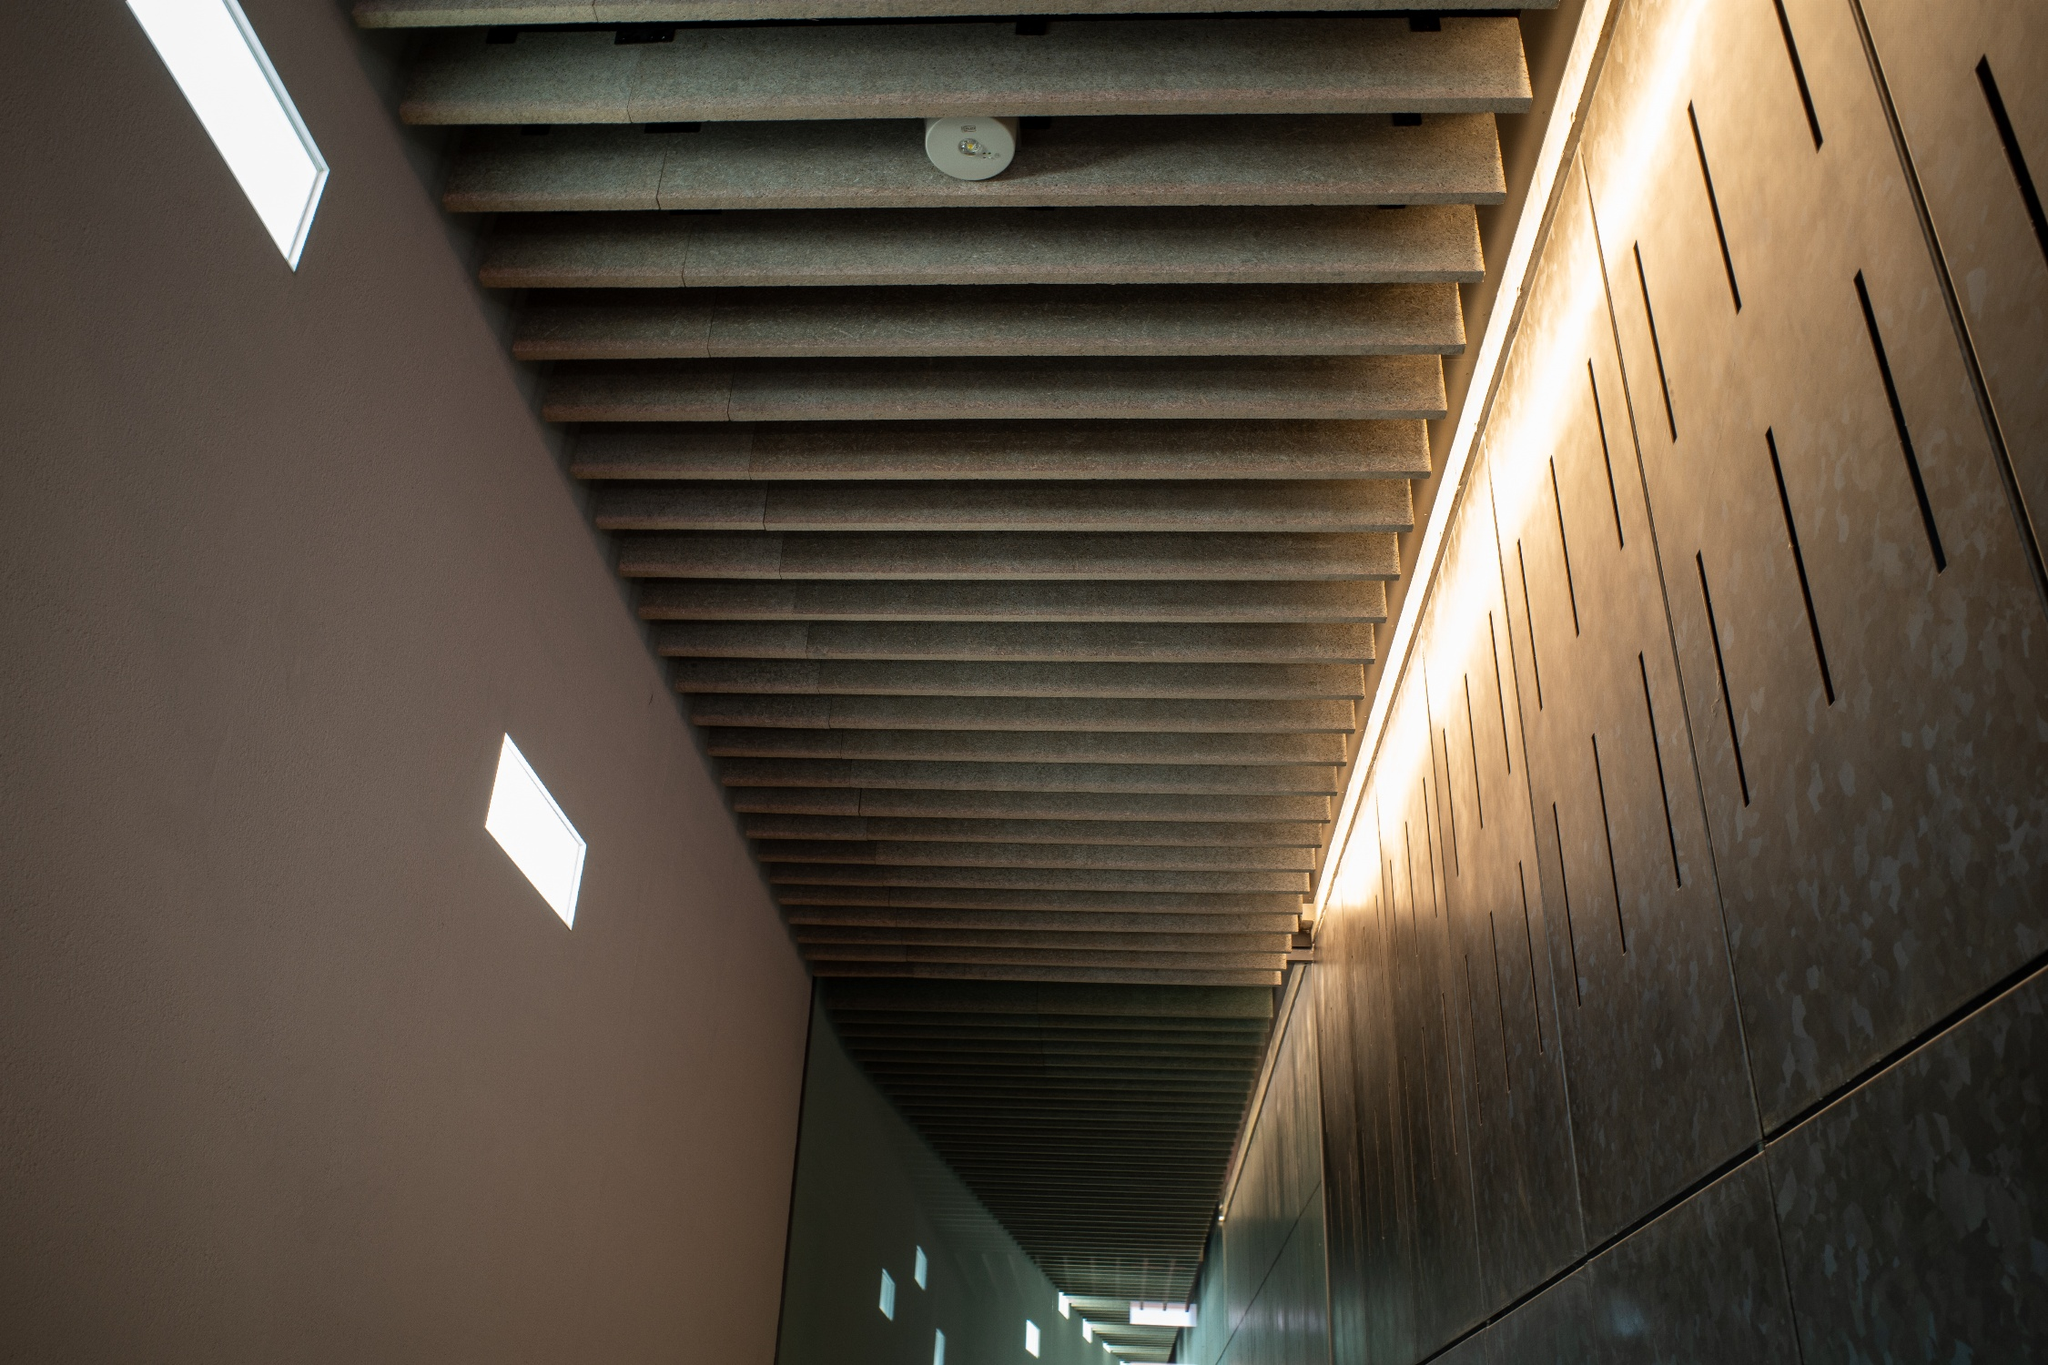Can you elaborate on the elements of the picture provided? The image presents a stunning modern architectural hallway. A textured, ribbed ceiling in soothing brown hues immediately captures the eye. It is intricately designed with square recessed lights, seamlessly adding both form and function. On one side of the hallway, small rectangular windows are sparsely yet thoughtfully set into light-colored stone walls, allowing natural light to punctuate the interior softly. The polished stone floor not only matches the walls but also reflects the soft glimmer of the overhead lights, enhancing the sense of depth and space. The photo's perspective, taken from the ground looking upward, dramatically elongates the hallway, imparting a profound sense of continuity and serenity. The minimalist design, characterized by clean lines and sparse decor, exudes tranquility and modern elegance. 